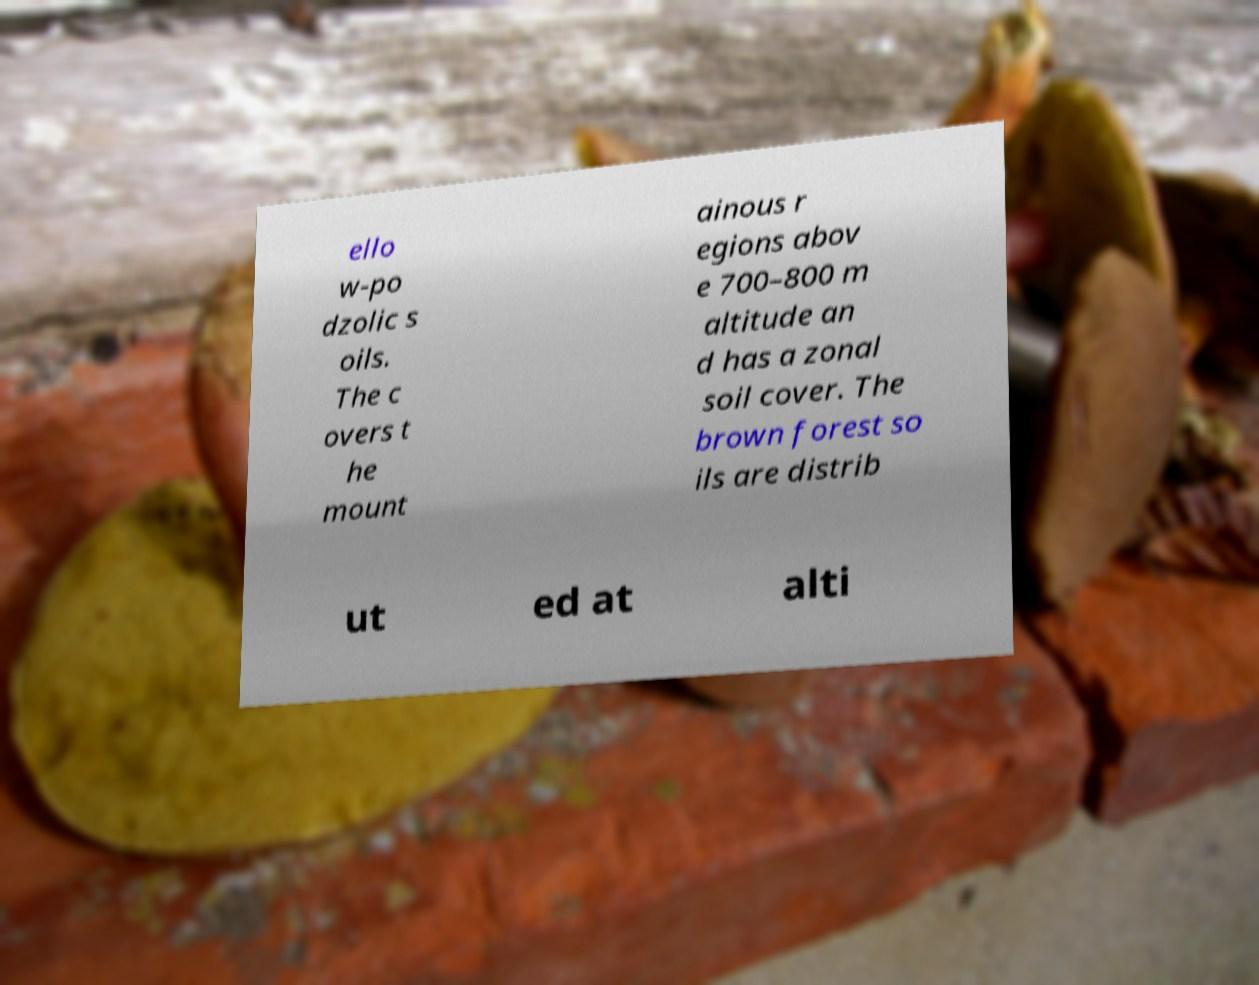Can you accurately transcribe the text from the provided image for me? ello w-po dzolic s oils. The c overs t he mount ainous r egions abov e 700–800 m altitude an d has a zonal soil cover. The brown forest so ils are distrib ut ed at alti 